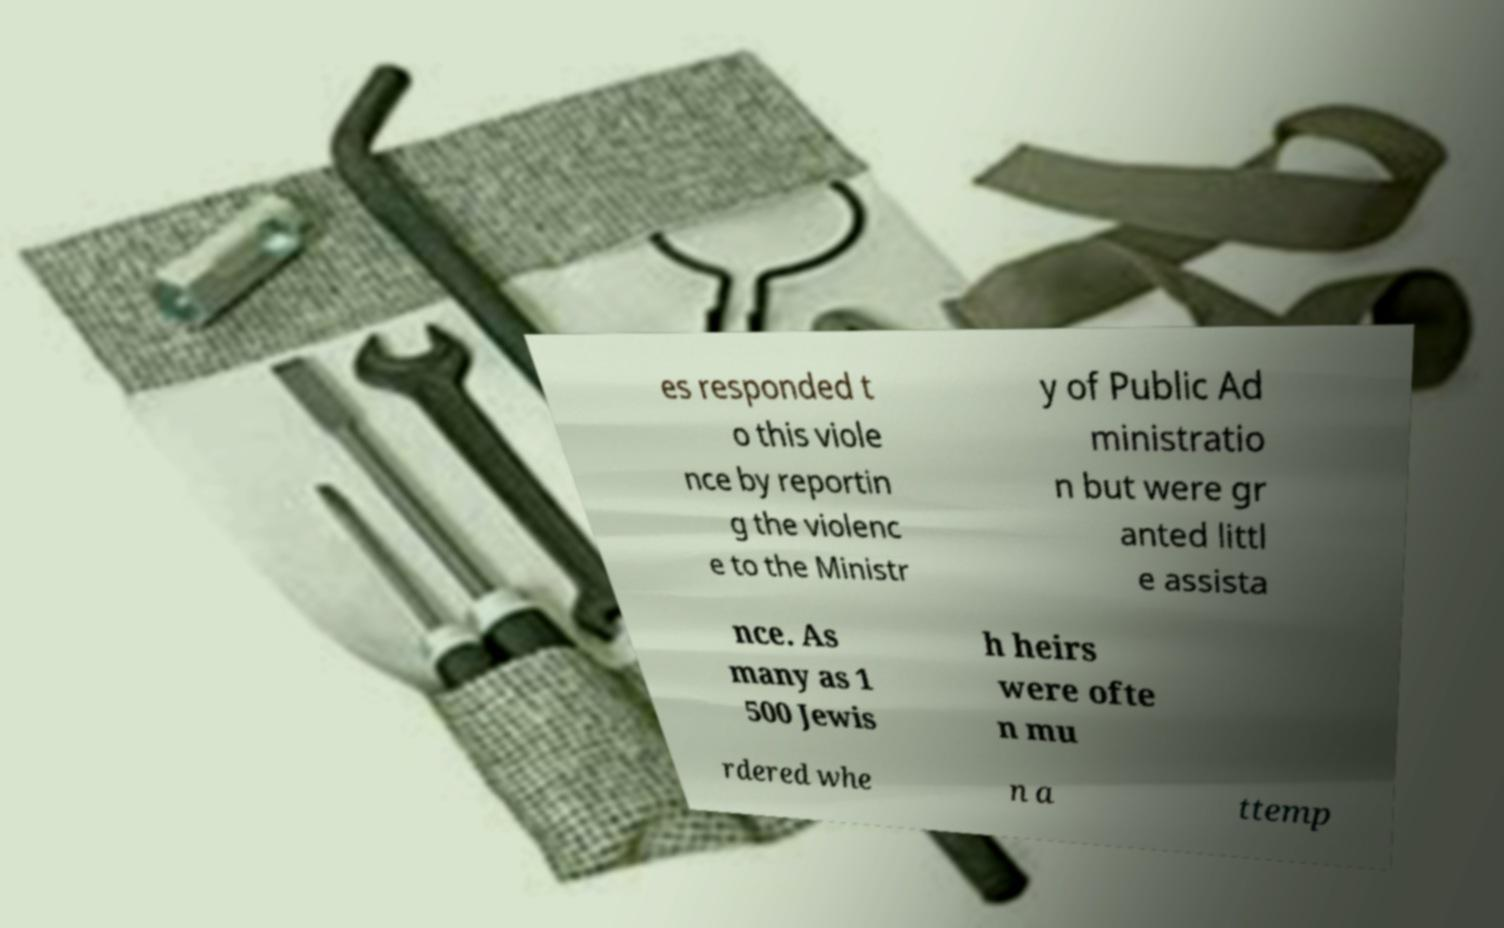Can you read and provide the text displayed in the image?This photo seems to have some interesting text. Can you extract and type it out for me? es responded t o this viole nce by reportin g the violenc e to the Ministr y of Public Ad ministratio n but were gr anted littl e assista nce. As many as 1 500 Jewis h heirs were ofte n mu rdered whe n a ttemp 